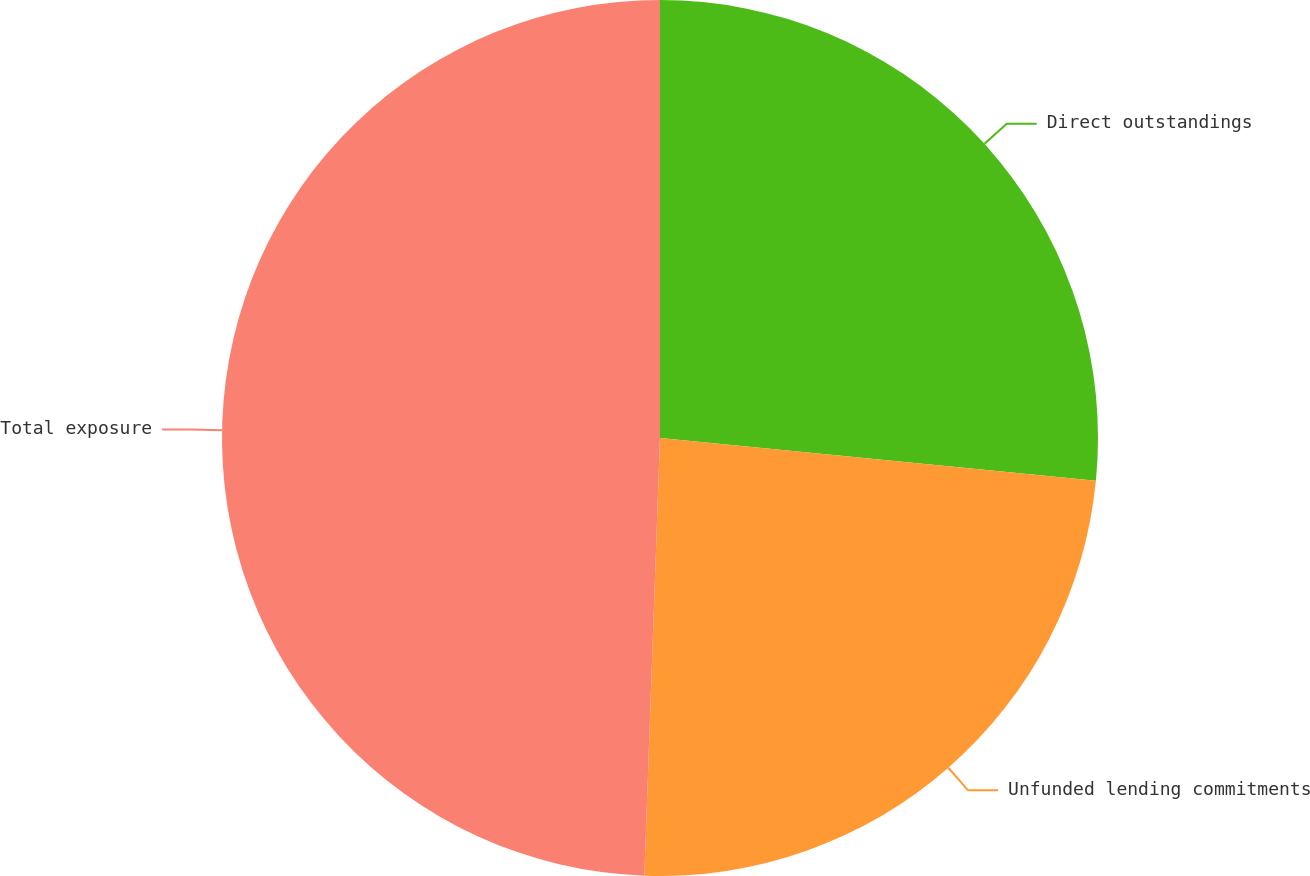Convert chart. <chart><loc_0><loc_0><loc_500><loc_500><pie_chart><fcel>Direct outstandings<fcel>Unfunded lending commitments<fcel>Total exposure<nl><fcel>26.56%<fcel>24.01%<fcel>49.43%<nl></chart> 